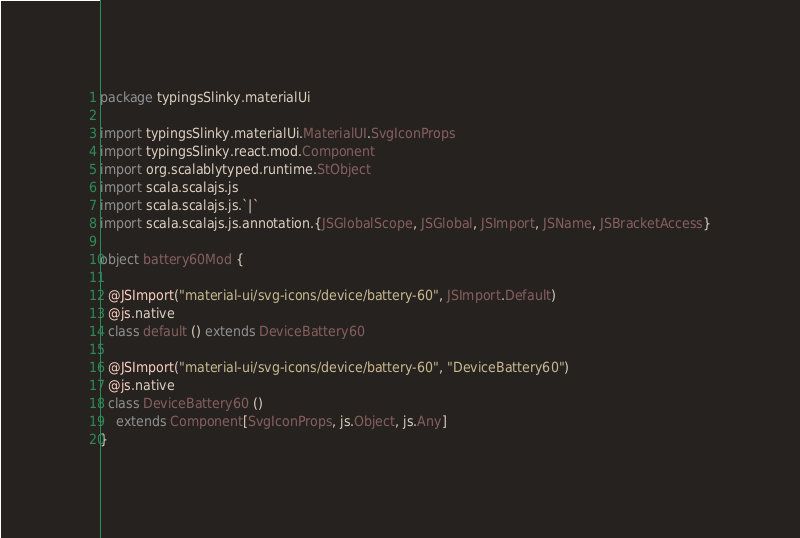<code> <loc_0><loc_0><loc_500><loc_500><_Scala_>package typingsSlinky.materialUi

import typingsSlinky.materialUi.MaterialUI.SvgIconProps
import typingsSlinky.react.mod.Component
import org.scalablytyped.runtime.StObject
import scala.scalajs.js
import scala.scalajs.js.`|`
import scala.scalajs.js.annotation.{JSGlobalScope, JSGlobal, JSImport, JSName, JSBracketAccess}

object battery60Mod {
  
  @JSImport("material-ui/svg-icons/device/battery-60", JSImport.Default)
  @js.native
  class default () extends DeviceBattery60
  
  @JSImport("material-ui/svg-icons/device/battery-60", "DeviceBattery60")
  @js.native
  class DeviceBattery60 ()
    extends Component[SvgIconProps, js.Object, js.Any]
}
</code> 